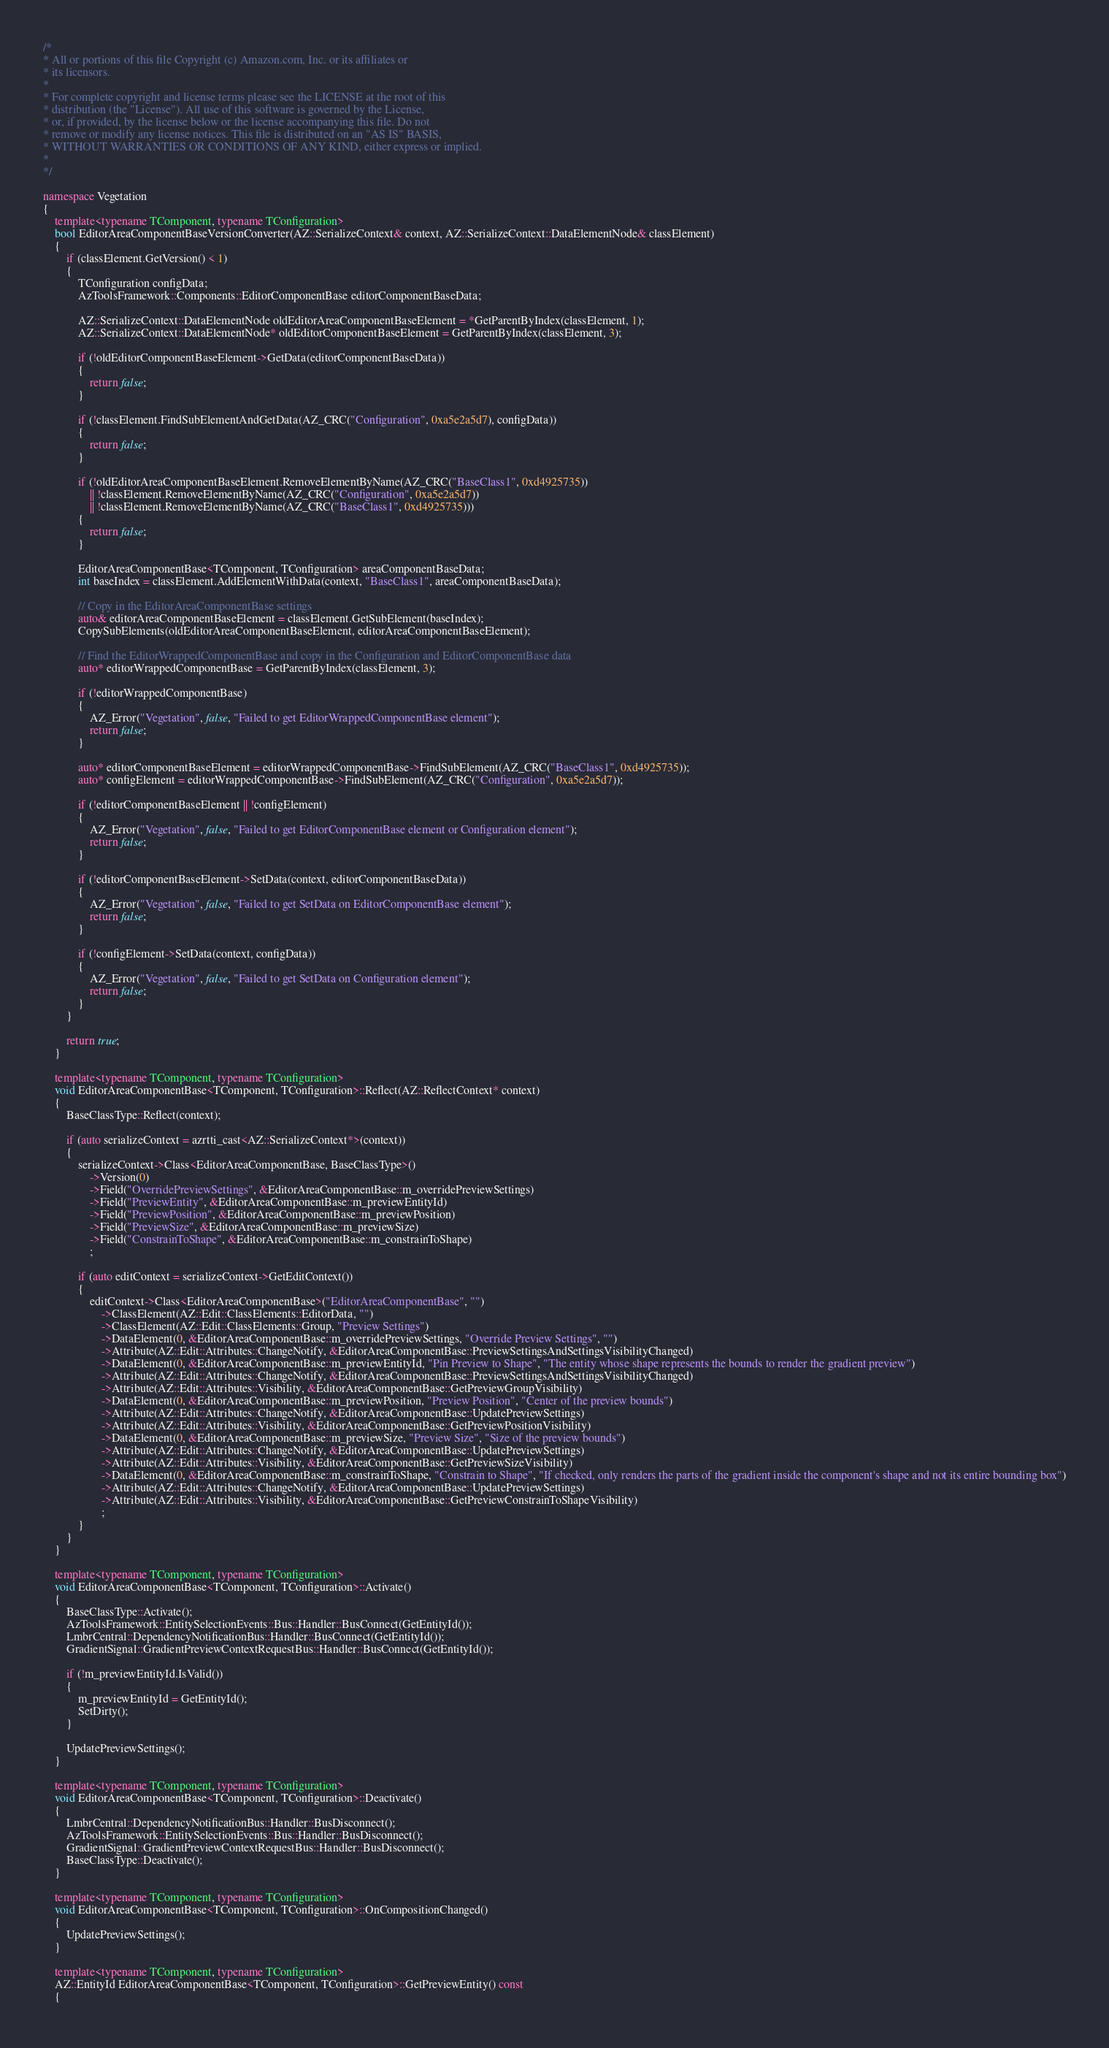<code> <loc_0><loc_0><loc_500><loc_500><_C++_>/*
* All or portions of this file Copyright (c) Amazon.com, Inc. or its affiliates or
* its licensors.
*
* For complete copyright and license terms please see the LICENSE at the root of this
* distribution (the "License"). All use of this software is governed by the License,
* or, if provided, by the license below or the license accompanying this file. Do not
* remove or modify any license notices. This file is distributed on an "AS IS" BASIS,
* WITHOUT WARRANTIES OR CONDITIONS OF ANY KIND, either express or implied.
*
*/

namespace Vegetation
{
    template<typename TComponent, typename TConfiguration>
    bool EditorAreaComponentBaseVersionConverter(AZ::SerializeContext& context, AZ::SerializeContext::DataElementNode& classElement)
    {
        if (classElement.GetVersion() < 1)
        {
            TConfiguration configData;
            AzToolsFramework::Components::EditorComponentBase editorComponentBaseData;

            AZ::SerializeContext::DataElementNode oldEditorAreaComponentBaseElement = *GetParentByIndex(classElement, 1);
            AZ::SerializeContext::DataElementNode* oldEditorComponentBaseElement = GetParentByIndex(classElement, 3);

            if (!oldEditorComponentBaseElement->GetData(editorComponentBaseData))
            {
                return false;
            }

            if (!classElement.FindSubElementAndGetData(AZ_CRC("Configuration", 0xa5e2a5d7), configData))
            {
                return false;
            }

            if (!oldEditorAreaComponentBaseElement.RemoveElementByName(AZ_CRC("BaseClass1", 0xd4925735))
                || !classElement.RemoveElementByName(AZ_CRC("Configuration", 0xa5e2a5d7))
                || !classElement.RemoveElementByName(AZ_CRC("BaseClass1", 0xd4925735)))
            {
                return false;
            }

            EditorAreaComponentBase<TComponent, TConfiguration> areaComponentBaseData;
            int baseIndex = classElement.AddElementWithData(context, "BaseClass1", areaComponentBaseData);

            // Copy in the EditorAreaComponentBase settings
            auto& editorAreaComponentBaseElement = classElement.GetSubElement(baseIndex);
            CopySubElements(oldEditorAreaComponentBaseElement, editorAreaComponentBaseElement);

            // Find the EditorWrappedComponentBase and copy in the Configuration and EditorComponentBase data
            auto* editorWrappedComponentBase = GetParentByIndex(classElement, 3);

            if (!editorWrappedComponentBase)
            {
                AZ_Error("Vegetation", false, "Failed to get EditorWrappedComponentBase element");
                return false;
            }

            auto* editorComponentBaseElement = editorWrappedComponentBase->FindSubElement(AZ_CRC("BaseClass1", 0xd4925735));
            auto* configElement = editorWrappedComponentBase->FindSubElement(AZ_CRC("Configuration", 0xa5e2a5d7));

            if (!editorComponentBaseElement || !configElement)
            {
                AZ_Error("Vegetation", false, "Failed to get EditorComponentBase element or Configuration element");
                return false;
            }

            if (!editorComponentBaseElement->SetData(context, editorComponentBaseData))
            {
                AZ_Error("Vegetation", false, "Failed to get SetData on EditorComponentBase element");
                return false;
            }

            if (!configElement->SetData(context, configData))
            {
                AZ_Error("Vegetation", false, "Failed to get SetData on Configuration element");
                return false;
            }
        }

        return true;
    }

    template<typename TComponent, typename TConfiguration>
    void EditorAreaComponentBase<TComponent, TConfiguration>::Reflect(AZ::ReflectContext* context)
    {
        BaseClassType::Reflect(context);

        if (auto serializeContext = azrtti_cast<AZ::SerializeContext*>(context))
        {
            serializeContext->Class<EditorAreaComponentBase, BaseClassType>()
                ->Version(0)
                ->Field("OverridePreviewSettings", &EditorAreaComponentBase::m_overridePreviewSettings)
                ->Field("PreviewEntity", &EditorAreaComponentBase::m_previewEntityId)
                ->Field("PreviewPosition", &EditorAreaComponentBase::m_previewPosition)
                ->Field("PreviewSize", &EditorAreaComponentBase::m_previewSize)
                ->Field("ConstrainToShape", &EditorAreaComponentBase::m_constrainToShape)
                ;

            if (auto editContext = serializeContext->GetEditContext())
            {
                editContext->Class<EditorAreaComponentBase>("EditorAreaComponentBase", "")
                    ->ClassElement(AZ::Edit::ClassElements::EditorData, "")
                    ->ClassElement(AZ::Edit::ClassElements::Group, "Preview Settings")
                    ->DataElement(0, &EditorAreaComponentBase::m_overridePreviewSettings, "Override Preview Settings", "")
                    ->Attribute(AZ::Edit::Attributes::ChangeNotify, &EditorAreaComponentBase::PreviewSettingsAndSettingsVisibilityChanged)
                    ->DataElement(0, &EditorAreaComponentBase::m_previewEntityId, "Pin Preview to Shape", "The entity whose shape represents the bounds to render the gradient preview")
                    ->Attribute(AZ::Edit::Attributes::ChangeNotify, &EditorAreaComponentBase::PreviewSettingsAndSettingsVisibilityChanged)
                    ->Attribute(AZ::Edit::Attributes::Visibility, &EditorAreaComponentBase::GetPreviewGroupVisibility)
                    ->DataElement(0, &EditorAreaComponentBase::m_previewPosition, "Preview Position", "Center of the preview bounds")
                    ->Attribute(AZ::Edit::Attributes::ChangeNotify, &EditorAreaComponentBase::UpdatePreviewSettings)
                    ->Attribute(AZ::Edit::Attributes::Visibility, &EditorAreaComponentBase::GetPreviewPositionVisibility)
                    ->DataElement(0, &EditorAreaComponentBase::m_previewSize, "Preview Size", "Size of the preview bounds")
                    ->Attribute(AZ::Edit::Attributes::ChangeNotify, &EditorAreaComponentBase::UpdatePreviewSettings)
                    ->Attribute(AZ::Edit::Attributes::Visibility, &EditorAreaComponentBase::GetPreviewSizeVisibility)
                    ->DataElement(0, &EditorAreaComponentBase::m_constrainToShape, "Constrain to Shape", "If checked, only renders the parts of the gradient inside the component's shape and not its entire bounding box")
                    ->Attribute(AZ::Edit::Attributes::ChangeNotify, &EditorAreaComponentBase::UpdatePreviewSettings)
                    ->Attribute(AZ::Edit::Attributes::Visibility, &EditorAreaComponentBase::GetPreviewConstrainToShapeVisibility)
                    ;
            }
        }
    }

    template<typename TComponent, typename TConfiguration>
    void EditorAreaComponentBase<TComponent, TConfiguration>::Activate()
    {
        BaseClassType::Activate();
        AzToolsFramework::EntitySelectionEvents::Bus::Handler::BusConnect(GetEntityId());
        LmbrCentral::DependencyNotificationBus::Handler::BusConnect(GetEntityId());
        GradientSignal::GradientPreviewContextRequestBus::Handler::BusConnect(GetEntityId());

        if (!m_previewEntityId.IsValid())
        {
            m_previewEntityId = GetEntityId();
            SetDirty();
        }

        UpdatePreviewSettings();
    }

    template<typename TComponent, typename TConfiguration>
    void EditorAreaComponentBase<TComponent, TConfiguration>::Deactivate()
    {
        LmbrCentral::DependencyNotificationBus::Handler::BusDisconnect();
        AzToolsFramework::EntitySelectionEvents::Bus::Handler::BusDisconnect();
        GradientSignal::GradientPreviewContextRequestBus::Handler::BusDisconnect();
        BaseClassType::Deactivate();
    }

    template<typename TComponent, typename TConfiguration>
    void EditorAreaComponentBase<TComponent, TConfiguration>::OnCompositionChanged()
    {
        UpdatePreviewSettings();
    }

    template<typename TComponent, typename TConfiguration>
    AZ::EntityId EditorAreaComponentBase<TComponent, TConfiguration>::GetPreviewEntity() const
    {</code> 